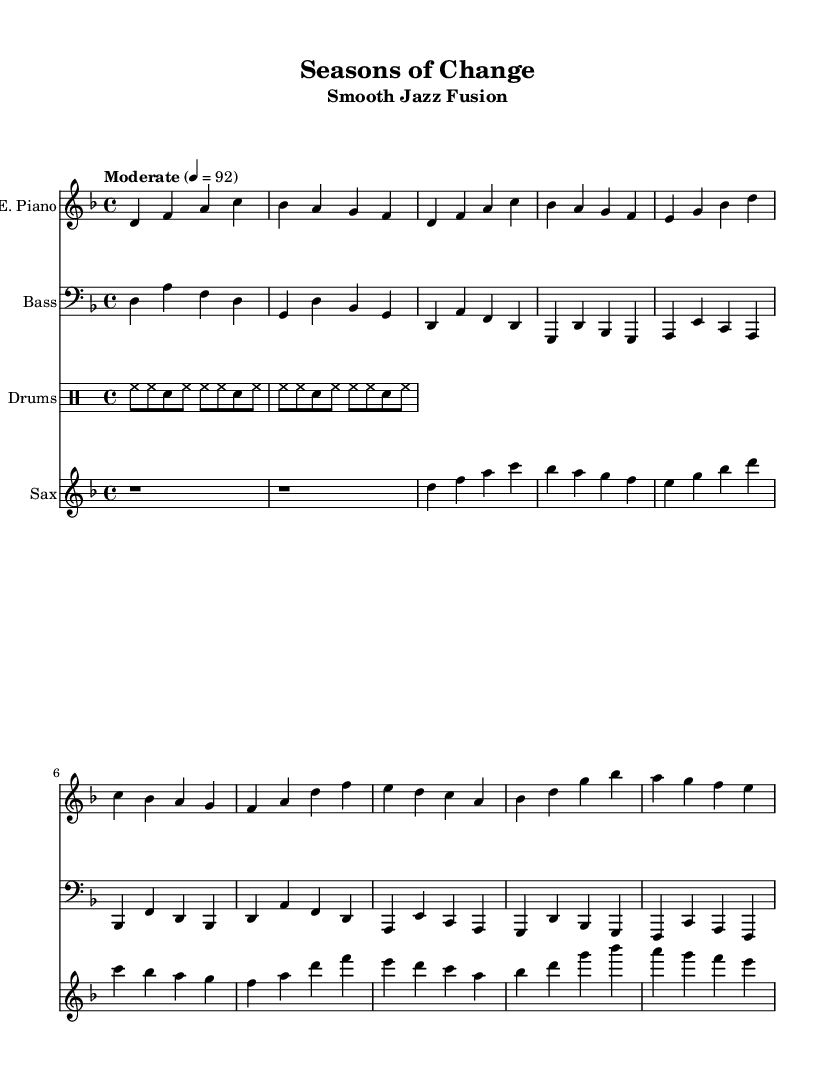What is the key signature of this music? The key signature is D minor, indicated by one flat (B flat) in the music sheet. D minor is the relative minor of F major, and the presence of one flat confirms this key.
Answer: D minor What is the time signature of this music? The time signature is 4/4, as shown in the beginning of the staff. This indicates that there are four beats in a measure and a quarter note receives one beat.
Answer: 4/4 What is the tempo of this music? The tempo marking indicates "Moderate" at a metronome marking of 92 beats per minute. This describes the speed at which the music should be played.
Answer: 92 How many measures are in the Chorus section? The Chorus section contains four measures, which can be counted directly from the music sheet, as each line of music typically represents a measure in the score.
Answer: 4 Which instrument is playing the bass line? The bass line is played by the Bass guitar, indicated by the staff marked "Bass." The music notates the lower range typically associated with the bass guitar.
Answer: Bass guitar What kind of drum pattern is used in this piece? The drum part features a basic jazz groove, characterized by a repeating pattern of hi-hat and snare hits. The notation indicates a common jazz style groove that establishes a steady rhythm.
Answer: Basic jazz groove What is the primary theme reflected in the music's structure? The music's structure emphasizes the transitions reflective of the seasons, with changes in dynamics and texture that suggest transformation, which can be inferred from the title "Seasons of Change."
Answer: Seasons 